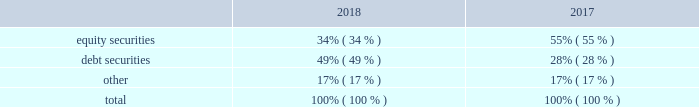Masco corporation notes to consolidated financial statements ( continued ) m .
Employee retirement plans ( continued ) plan assets .
Our qualified defined-benefit pension plan weighted average asset allocation , which is based upon fair value , was as follows: .
For our qualified defined-benefit pension plans , we have adopted accounting guidance that defines fair value , establishes a framework for measuring fair value and prescribes disclosures about fair value measurements .
Accounting guidance defines fair value as "the price that would be received to sell an asset or paid to transfer a liability in an orderly transaction between market participants at the measurement date." following is a description of the valuation methodologies used for assets measured at fair value .
There have been no changes in the methodologies used at december 31 , 2018 compared to december 31 , 2017 .
Common and preferred stocks and short-term and other investments : valued at the closing price reported on the active market on which the individual securities are traded or based on the active market for similar securities .
Certain investments are valued based on net asset value ( "nav" ) , which approximates fair value .
Such basis is determined by referencing the respective fund's underlying assets .
There are no unfunded commitments or other restrictions associated with these investments .
Private equity and hedge funds : valued based on an estimated fair value using either a market approach or an income approach , both of which require a significant degree of judgment .
There is no active trading market for these investments and they are generally illiquid .
Due to the significant unobservable inputs , the fair value measurements used to estimate fair value are a level 3 input .
Certain investments are valued based on nav , which approximates fair value .
Such basis is determined by referencing the respective fund's underlying assets .
There are no unfunded commitments or other restrictions associated with the investments valued at nav .
Corporate , government and other debt securities : valued based on either the closing price reported on the active market on which the individual securities are traded or using pricing models maximizing the use of observable inputs for similar securities .
This includes basing value on yields currently available on comparable securities of issuers with similar credit ratings .
Certain investments are valued based on nav , which approximates fair value .
Such basis is determined by referencing the respective fund's underlying assets .
There are unfunded commitments of $ 1 million and no other restrictions associated with these investments .
Common collective trust fund : valued based on an amortized cost basis , which approximates fair value .
Such basis is determined by reference to the respective fund's underlying assets , which are primarily cash equivalents .
There are no unfunded commitments or other restrictions associated with this fund .
Buy-in annuity : valued based on the associated benefit obligation for which the buy-in annuity covers the benefits , which approximates fair value .
Such basis is determined based on various assumptions , including the discount rate , long-term rate of return on plan assets and mortality rate .
The methods described above may produce a fair value calculation that may not be indicative of net realizable value or reflective of future fair values .
Furthermore , while we believe our valuation methods are appropriate and consistent with other market participants , the use of different methodologies or assumptions to determine the fair value of certain financial instruments could result in a different fair value measurement at the reporting date .
The following tables set forth , by level within the fair value hierarchy , the qualified defined-benefit pension plan assets at fair value as of december 31 , 2018 and 2017 , as well as those valued at nav using the practical expedient , which approximates fair value , in millions. .
What was the percent of the increase in the debt securities? 
Rationale: the debt securities increased by 75% from 2017 to 2018
Computations: ((49 - 28) / 28)
Answer: 0.75. 